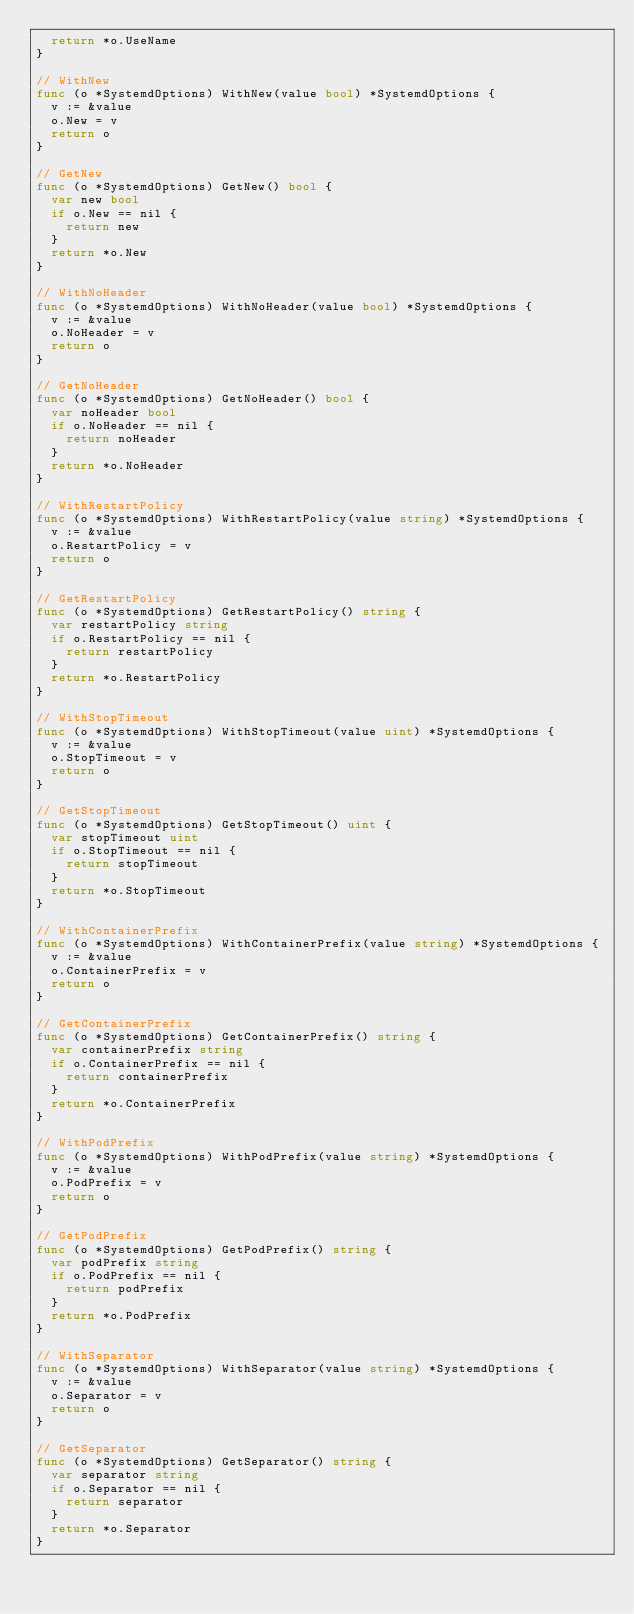Convert code to text. <code><loc_0><loc_0><loc_500><loc_500><_Go_>	return *o.UseName
}

// WithNew
func (o *SystemdOptions) WithNew(value bool) *SystemdOptions {
	v := &value
	o.New = v
	return o
}

// GetNew
func (o *SystemdOptions) GetNew() bool {
	var new bool
	if o.New == nil {
		return new
	}
	return *o.New
}

// WithNoHeader
func (o *SystemdOptions) WithNoHeader(value bool) *SystemdOptions {
	v := &value
	o.NoHeader = v
	return o
}

// GetNoHeader
func (o *SystemdOptions) GetNoHeader() bool {
	var noHeader bool
	if o.NoHeader == nil {
		return noHeader
	}
	return *o.NoHeader
}

// WithRestartPolicy
func (o *SystemdOptions) WithRestartPolicy(value string) *SystemdOptions {
	v := &value
	o.RestartPolicy = v
	return o
}

// GetRestartPolicy
func (o *SystemdOptions) GetRestartPolicy() string {
	var restartPolicy string
	if o.RestartPolicy == nil {
		return restartPolicy
	}
	return *o.RestartPolicy
}

// WithStopTimeout
func (o *SystemdOptions) WithStopTimeout(value uint) *SystemdOptions {
	v := &value
	o.StopTimeout = v
	return o
}

// GetStopTimeout
func (o *SystemdOptions) GetStopTimeout() uint {
	var stopTimeout uint
	if o.StopTimeout == nil {
		return stopTimeout
	}
	return *o.StopTimeout
}

// WithContainerPrefix
func (o *SystemdOptions) WithContainerPrefix(value string) *SystemdOptions {
	v := &value
	o.ContainerPrefix = v
	return o
}

// GetContainerPrefix
func (o *SystemdOptions) GetContainerPrefix() string {
	var containerPrefix string
	if o.ContainerPrefix == nil {
		return containerPrefix
	}
	return *o.ContainerPrefix
}

// WithPodPrefix
func (o *SystemdOptions) WithPodPrefix(value string) *SystemdOptions {
	v := &value
	o.PodPrefix = v
	return o
}

// GetPodPrefix
func (o *SystemdOptions) GetPodPrefix() string {
	var podPrefix string
	if o.PodPrefix == nil {
		return podPrefix
	}
	return *o.PodPrefix
}

// WithSeparator
func (o *SystemdOptions) WithSeparator(value string) *SystemdOptions {
	v := &value
	o.Separator = v
	return o
}

// GetSeparator
func (o *SystemdOptions) GetSeparator() string {
	var separator string
	if o.Separator == nil {
		return separator
	}
	return *o.Separator
}
</code> 